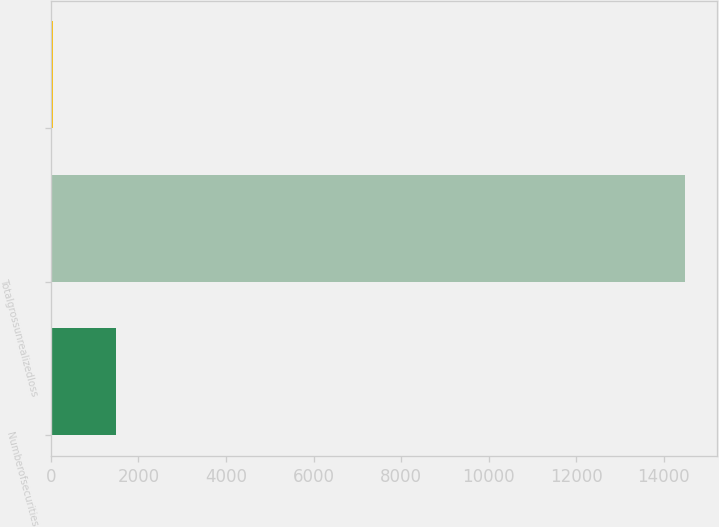<chart> <loc_0><loc_0><loc_500><loc_500><bar_chart><fcel>Numberofsecurities<fcel>Totalgrossunrealizedloss<fcel>Unnamed: 2<nl><fcel>1493.5<fcel>14485<fcel>50<nl></chart> 